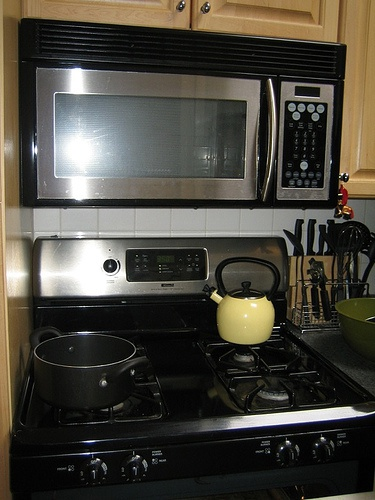Describe the objects in this image and their specific colors. I can see oven in olive, black, white, and gray tones, microwave in olive, black, gray, darkgray, and white tones, bowl in olive, black, and darkgreen tones, spoon in olive, black, darkgray, and gray tones, and knife in olive, black, and gray tones in this image. 